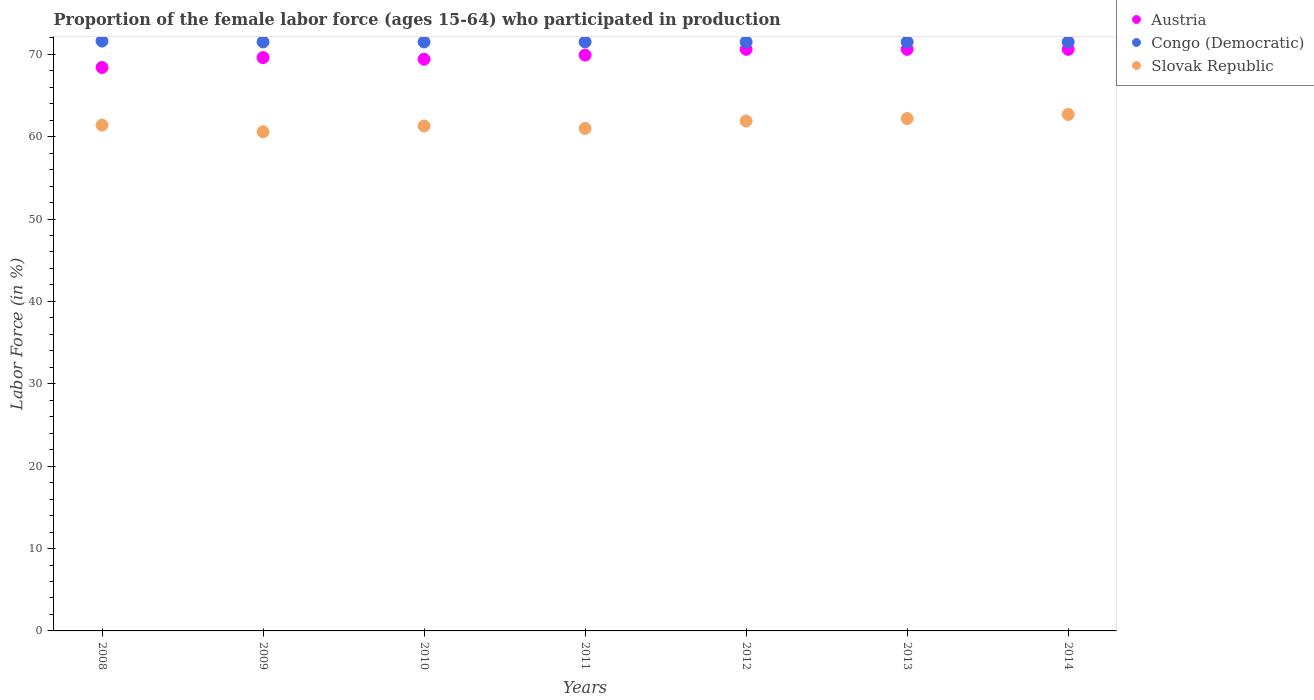How many different coloured dotlines are there?
Your answer should be compact. 3. Is the number of dotlines equal to the number of legend labels?
Ensure brevity in your answer.  Yes. What is the proportion of the female labor force who participated in production in Slovak Republic in 2012?
Keep it short and to the point. 61.9. Across all years, what is the maximum proportion of the female labor force who participated in production in Congo (Democratic)?
Offer a very short reply. 71.6. Across all years, what is the minimum proportion of the female labor force who participated in production in Austria?
Make the answer very short. 68.4. In which year was the proportion of the female labor force who participated in production in Congo (Democratic) minimum?
Offer a terse response. 2009. What is the total proportion of the female labor force who participated in production in Congo (Democratic) in the graph?
Your answer should be very brief. 500.6. What is the difference between the proportion of the female labor force who participated in production in Austria in 2011 and that in 2014?
Provide a succinct answer. -0.7. What is the difference between the proportion of the female labor force who participated in production in Congo (Democratic) in 2014 and the proportion of the female labor force who participated in production in Slovak Republic in 2012?
Make the answer very short. 9.6. What is the average proportion of the female labor force who participated in production in Austria per year?
Provide a short and direct response. 69.87. In the year 2014, what is the difference between the proportion of the female labor force who participated in production in Austria and proportion of the female labor force who participated in production in Congo (Democratic)?
Your answer should be very brief. -0.9. What is the ratio of the proportion of the female labor force who participated in production in Slovak Republic in 2008 to that in 2014?
Offer a very short reply. 0.98. Is the proportion of the female labor force who participated in production in Austria in 2008 less than that in 2014?
Offer a very short reply. Yes. Is the difference between the proportion of the female labor force who participated in production in Austria in 2008 and 2013 greater than the difference between the proportion of the female labor force who participated in production in Congo (Democratic) in 2008 and 2013?
Make the answer very short. No. What is the difference between the highest and the lowest proportion of the female labor force who participated in production in Austria?
Give a very brief answer. 2.2. Is the proportion of the female labor force who participated in production in Slovak Republic strictly less than the proportion of the female labor force who participated in production in Congo (Democratic) over the years?
Provide a succinct answer. Yes. How many years are there in the graph?
Offer a very short reply. 7. What is the difference between two consecutive major ticks on the Y-axis?
Offer a terse response. 10. Are the values on the major ticks of Y-axis written in scientific E-notation?
Your response must be concise. No. Does the graph contain grids?
Offer a terse response. No. Where does the legend appear in the graph?
Give a very brief answer. Top right. What is the title of the graph?
Give a very brief answer. Proportion of the female labor force (ages 15-64) who participated in production. What is the label or title of the X-axis?
Provide a succinct answer. Years. What is the label or title of the Y-axis?
Provide a short and direct response. Labor Force (in %). What is the Labor Force (in %) in Austria in 2008?
Your response must be concise. 68.4. What is the Labor Force (in %) in Congo (Democratic) in 2008?
Ensure brevity in your answer.  71.6. What is the Labor Force (in %) in Slovak Republic in 2008?
Provide a succinct answer. 61.4. What is the Labor Force (in %) in Austria in 2009?
Your answer should be compact. 69.6. What is the Labor Force (in %) of Congo (Democratic) in 2009?
Your answer should be compact. 71.5. What is the Labor Force (in %) of Slovak Republic in 2009?
Make the answer very short. 60.6. What is the Labor Force (in %) of Austria in 2010?
Your answer should be very brief. 69.4. What is the Labor Force (in %) in Congo (Democratic) in 2010?
Your response must be concise. 71.5. What is the Labor Force (in %) of Slovak Republic in 2010?
Your answer should be very brief. 61.3. What is the Labor Force (in %) of Austria in 2011?
Provide a succinct answer. 69.9. What is the Labor Force (in %) of Congo (Democratic) in 2011?
Provide a short and direct response. 71.5. What is the Labor Force (in %) of Slovak Republic in 2011?
Provide a succinct answer. 61. What is the Labor Force (in %) in Austria in 2012?
Ensure brevity in your answer.  70.6. What is the Labor Force (in %) of Congo (Democratic) in 2012?
Offer a terse response. 71.5. What is the Labor Force (in %) of Slovak Republic in 2012?
Your response must be concise. 61.9. What is the Labor Force (in %) in Austria in 2013?
Give a very brief answer. 70.6. What is the Labor Force (in %) in Congo (Democratic) in 2013?
Make the answer very short. 71.5. What is the Labor Force (in %) in Slovak Republic in 2013?
Keep it short and to the point. 62.2. What is the Labor Force (in %) of Austria in 2014?
Provide a succinct answer. 70.6. What is the Labor Force (in %) of Congo (Democratic) in 2014?
Keep it short and to the point. 71.5. What is the Labor Force (in %) of Slovak Republic in 2014?
Your answer should be very brief. 62.7. Across all years, what is the maximum Labor Force (in %) of Austria?
Provide a short and direct response. 70.6. Across all years, what is the maximum Labor Force (in %) of Congo (Democratic)?
Give a very brief answer. 71.6. Across all years, what is the maximum Labor Force (in %) of Slovak Republic?
Offer a very short reply. 62.7. Across all years, what is the minimum Labor Force (in %) in Austria?
Offer a terse response. 68.4. Across all years, what is the minimum Labor Force (in %) in Congo (Democratic)?
Provide a succinct answer. 71.5. Across all years, what is the minimum Labor Force (in %) in Slovak Republic?
Your response must be concise. 60.6. What is the total Labor Force (in %) in Austria in the graph?
Make the answer very short. 489.1. What is the total Labor Force (in %) in Congo (Democratic) in the graph?
Offer a very short reply. 500.6. What is the total Labor Force (in %) of Slovak Republic in the graph?
Provide a short and direct response. 431.1. What is the difference between the Labor Force (in %) of Congo (Democratic) in 2008 and that in 2009?
Make the answer very short. 0.1. What is the difference between the Labor Force (in %) of Slovak Republic in 2008 and that in 2009?
Provide a short and direct response. 0.8. What is the difference between the Labor Force (in %) in Slovak Republic in 2008 and that in 2010?
Provide a short and direct response. 0.1. What is the difference between the Labor Force (in %) of Congo (Democratic) in 2008 and that in 2011?
Keep it short and to the point. 0.1. What is the difference between the Labor Force (in %) of Slovak Republic in 2008 and that in 2011?
Keep it short and to the point. 0.4. What is the difference between the Labor Force (in %) in Slovak Republic in 2008 and that in 2012?
Offer a very short reply. -0.5. What is the difference between the Labor Force (in %) in Slovak Republic in 2008 and that in 2014?
Ensure brevity in your answer.  -1.3. What is the difference between the Labor Force (in %) of Austria in 2009 and that in 2010?
Ensure brevity in your answer.  0.2. What is the difference between the Labor Force (in %) in Slovak Republic in 2009 and that in 2010?
Your response must be concise. -0.7. What is the difference between the Labor Force (in %) in Austria in 2009 and that in 2011?
Give a very brief answer. -0.3. What is the difference between the Labor Force (in %) of Congo (Democratic) in 2009 and that in 2011?
Give a very brief answer. 0. What is the difference between the Labor Force (in %) in Austria in 2009 and that in 2012?
Your answer should be compact. -1. What is the difference between the Labor Force (in %) of Slovak Republic in 2009 and that in 2012?
Provide a succinct answer. -1.3. What is the difference between the Labor Force (in %) in Austria in 2009 and that in 2013?
Offer a very short reply. -1. What is the difference between the Labor Force (in %) in Congo (Democratic) in 2009 and that in 2013?
Provide a short and direct response. 0. What is the difference between the Labor Force (in %) of Slovak Republic in 2009 and that in 2013?
Offer a terse response. -1.6. What is the difference between the Labor Force (in %) of Congo (Democratic) in 2009 and that in 2014?
Give a very brief answer. 0. What is the difference between the Labor Force (in %) of Slovak Republic in 2009 and that in 2014?
Your response must be concise. -2.1. What is the difference between the Labor Force (in %) in Austria in 2010 and that in 2011?
Your answer should be compact. -0.5. What is the difference between the Labor Force (in %) in Congo (Democratic) in 2010 and that in 2011?
Provide a succinct answer. 0. What is the difference between the Labor Force (in %) in Slovak Republic in 2010 and that in 2011?
Give a very brief answer. 0.3. What is the difference between the Labor Force (in %) in Austria in 2010 and that in 2012?
Provide a succinct answer. -1.2. What is the difference between the Labor Force (in %) of Congo (Democratic) in 2010 and that in 2012?
Give a very brief answer. 0. What is the difference between the Labor Force (in %) of Congo (Democratic) in 2010 and that in 2014?
Your answer should be compact. 0. What is the difference between the Labor Force (in %) in Congo (Democratic) in 2011 and that in 2012?
Your answer should be very brief. 0. What is the difference between the Labor Force (in %) in Slovak Republic in 2011 and that in 2012?
Give a very brief answer. -0.9. What is the difference between the Labor Force (in %) of Congo (Democratic) in 2011 and that in 2013?
Keep it short and to the point. 0. What is the difference between the Labor Force (in %) in Slovak Republic in 2011 and that in 2013?
Give a very brief answer. -1.2. What is the difference between the Labor Force (in %) in Slovak Republic in 2012 and that in 2013?
Your response must be concise. -0.3. What is the difference between the Labor Force (in %) in Congo (Democratic) in 2012 and that in 2014?
Offer a terse response. 0. What is the difference between the Labor Force (in %) of Austria in 2008 and the Labor Force (in %) of Congo (Democratic) in 2009?
Give a very brief answer. -3.1. What is the difference between the Labor Force (in %) in Congo (Democratic) in 2008 and the Labor Force (in %) in Slovak Republic in 2009?
Your answer should be compact. 11. What is the difference between the Labor Force (in %) in Austria in 2008 and the Labor Force (in %) in Congo (Democratic) in 2010?
Your answer should be very brief. -3.1. What is the difference between the Labor Force (in %) of Austria in 2008 and the Labor Force (in %) of Slovak Republic in 2010?
Offer a terse response. 7.1. What is the difference between the Labor Force (in %) in Congo (Democratic) in 2008 and the Labor Force (in %) in Slovak Republic in 2010?
Your answer should be very brief. 10.3. What is the difference between the Labor Force (in %) of Austria in 2008 and the Labor Force (in %) of Congo (Democratic) in 2011?
Your response must be concise. -3.1. What is the difference between the Labor Force (in %) of Austria in 2008 and the Labor Force (in %) of Slovak Republic in 2011?
Offer a very short reply. 7.4. What is the difference between the Labor Force (in %) of Austria in 2008 and the Labor Force (in %) of Congo (Democratic) in 2012?
Offer a terse response. -3.1. What is the difference between the Labor Force (in %) in Austria in 2008 and the Labor Force (in %) in Slovak Republic in 2012?
Provide a succinct answer. 6.5. What is the difference between the Labor Force (in %) in Austria in 2008 and the Labor Force (in %) in Congo (Democratic) in 2013?
Keep it short and to the point. -3.1. What is the difference between the Labor Force (in %) of Congo (Democratic) in 2008 and the Labor Force (in %) of Slovak Republic in 2013?
Give a very brief answer. 9.4. What is the difference between the Labor Force (in %) in Congo (Democratic) in 2008 and the Labor Force (in %) in Slovak Republic in 2014?
Offer a very short reply. 8.9. What is the difference between the Labor Force (in %) of Congo (Democratic) in 2009 and the Labor Force (in %) of Slovak Republic in 2010?
Keep it short and to the point. 10.2. What is the difference between the Labor Force (in %) of Austria in 2009 and the Labor Force (in %) of Congo (Democratic) in 2011?
Provide a short and direct response. -1.9. What is the difference between the Labor Force (in %) in Austria in 2009 and the Labor Force (in %) in Slovak Republic in 2011?
Ensure brevity in your answer.  8.6. What is the difference between the Labor Force (in %) in Austria in 2009 and the Labor Force (in %) in Congo (Democratic) in 2012?
Offer a terse response. -1.9. What is the difference between the Labor Force (in %) of Austria in 2009 and the Labor Force (in %) of Slovak Republic in 2012?
Offer a very short reply. 7.7. What is the difference between the Labor Force (in %) of Congo (Democratic) in 2009 and the Labor Force (in %) of Slovak Republic in 2012?
Your answer should be very brief. 9.6. What is the difference between the Labor Force (in %) of Austria in 2009 and the Labor Force (in %) of Congo (Democratic) in 2013?
Keep it short and to the point. -1.9. What is the difference between the Labor Force (in %) in Austria in 2009 and the Labor Force (in %) in Congo (Democratic) in 2014?
Offer a terse response. -1.9. What is the difference between the Labor Force (in %) of Congo (Democratic) in 2009 and the Labor Force (in %) of Slovak Republic in 2014?
Provide a short and direct response. 8.8. What is the difference between the Labor Force (in %) in Congo (Democratic) in 2010 and the Labor Force (in %) in Slovak Republic in 2011?
Provide a succinct answer. 10.5. What is the difference between the Labor Force (in %) of Austria in 2010 and the Labor Force (in %) of Slovak Republic in 2012?
Make the answer very short. 7.5. What is the difference between the Labor Force (in %) in Austria in 2010 and the Labor Force (in %) in Slovak Republic in 2013?
Offer a terse response. 7.2. What is the difference between the Labor Force (in %) of Congo (Democratic) in 2010 and the Labor Force (in %) of Slovak Republic in 2013?
Ensure brevity in your answer.  9.3. What is the difference between the Labor Force (in %) in Austria in 2010 and the Labor Force (in %) in Slovak Republic in 2014?
Offer a terse response. 6.7. What is the difference between the Labor Force (in %) in Congo (Democratic) in 2010 and the Labor Force (in %) in Slovak Republic in 2014?
Your response must be concise. 8.8. What is the difference between the Labor Force (in %) of Austria in 2011 and the Labor Force (in %) of Congo (Democratic) in 2012?
Your response must be concise. -1.6. What is the difference between the Labor Force (in %) in Congo (Democratic) in 2011 and the Labor Force (in %) in Slovak Republic in 2013?
Give a very brief answer. 9.3. What is the difference between the Labor Force (in %) in Austria in 2011 and the Labor Force (in %) in Slovak Republic in 2014?
Offer a terse response. 7.2. What is the difference between the Labor Force (in %) of Austria in 2012 and the Labor Force (in %) of Congo (Democratic) in 2013?
Offer a terse response. -0.9. What is the difference between the Labor Force (in %) of Austria in 2012 and the Labor Force (in %) of Congo (Democratic) in 2014?
Your answer should be very brief. -0.9. What is the difference between the Labor Force (in %) in Austria in 2012 and the Labor Force (in %) in Slovak Republic in 2014?
Provide a short and direct response. 7.9. What is the difference between the Labor Force (in %) in Congo (Democratic) in 2012 and the Labor Force (in %) in Slovak Republic in 2014?
Ensure brevity in your answer.  8.8. What is the difference between the Labor Force (in %) of Congo (Democratic) in 2013 and the Labor Force (in %) of Slovak Republic in 2014?
Your response must be concise. 8.8. What is the average Labor Force (in %) of Austria per year?
Ensure brevity in your answer.  69.87. What is the average Labor Force (in %) in Congo (Democratic) per year?
Your answer should be very brief. 71.51. What is the average Labor Force (in %) in Slovak Republic per year?
Give a very brief answer. 61.59. In the year 2008, what is the difference between the Labor Force (in %) in Austria and Labor Force (in %) in Congo (Democratic)?
Your answer should be compact. -3.2. In the year 2009, what is the difference between the Labor Force (in %) of Austria and Labor Force (in %) of Congo (Democratic)?
Provide a succinct answer. -1.9. In the year 2009, what is the difference between the Labor Force (in %) of Congo (Democratic) and Labor Force (in %) of Slovak Republic?
Offer a very short reply. 10.9. In the year 2010, what is the difference between the Labor Force (in %) in Austria and Labor Force (in %) in Congo (Democratic)?
Offer a very short reply. -2.1. In the year 2010, what is the difference between the Labor Force (in %) in Congo (Democratic) and Labor Force (in %) in Slovak Republic?
Your answer should be very brief. 10.2. In the year 2011, what is the difference between the Labor Force (in %) in Austria and Labor Force (in %) in Congo (Democratic)?
Provide a short and direct response. -1.6. In the year 2011, what is the difference between the Labor Force (in %) of Congo (Democratic) and Labor Force (in %) of Slovak Republic?
Make the answer very short. 10.5. In the year 2013, what is the difference between the Labor Force (in %) of Austria and Labor Force (in %) of Congo (Democratic)?
Your answer should be very brief. -0.9. In the year 2013, what is the difference between the Labor Force (in %) of Austria and Labor Force (in %) of Slovak Republic?
Offer a very short reply. 8.4. In the year 2013, what is the difference between the Labor Force (in %) in Congo (Democratic) and Labor Force (in %) in Slovak Republic?
Make the answer very short. 9.3. In the year 2014, what is the difference between the Labor Force (in %) in Congo (Democratic) and Labor Force (in %) in Slovak Republic?
Offer a terse response. 8.8. What is the ratio of the Labor Force (in %) in Austria in 2008 to that in 2009?
Offer a terse response. 0.98. What is the ratio of the Labor Force (in %) of Congo (Democratic) in 2008 to that in 2009?
Ensure brevity in your answer.  1. What is the ratio of the Labor Force (in %) in Slovak Republic in 2008 to that in 2009?
Provide a short and direct response. 1.01. What is the ratio of the Labor Force (in %) of Austria in 2008 to that in 2010?
Provide a succinct answer. 0.99. What is the ratio of the Labor Force (in %) in Congo (Democratic) in 2008 to that in 2010?
Provide a short and direct response. 1. What is the ratio of the Labor Force (in %) of Austria in 2008 to that in 2011?
Provide a succinct answer. 0.98. What is the ratio of the Labor Force (in %) of Slovak Republic in 2008 to that in 2011?
Offer a terse response. 1.01. What is the ratio of the Labor Force (in %) in Austria in 2008 to that in 2012?
Offer a terse response. 0.97. What is the ratio of the Labor Force (in %) of Congo (Democratic) in 2008 to that in 2012?
Ensure brevity in your answer.  1. What is the ratio of the Labor Force (in %) in Slovak Republic in 2008 to that in 2012?
Provide a succinct answer. 0.99. What is the ratio of the Labor Force (in %) in Austria in 2008 to that in 2013?
Give a very brief answer. 0.97. What is the ratio of the Labor Force (in %) in Slovak Republic in 2008 to that in 2013?
Provide a short and direct response. 0.99. What is the ratio of the Labor Force (in %) of Austria in 2008 to that in 2014?
Give a very brief answer. 0.97. What is the ratio of the Labor Force (in %) of Congo (Democratic) in 2008 to that in 2014?
Your response must be concise. 1. What is the ratio of the Labor Force (in %) in Slovak Republic in 2008 to that in 2014?
Provide a short and direct response. 0.98. What is the ratio of the Labor Force (in %) of Slovak Republic in 2009 to that in 2010?
Provide a succinct answer. 0.99. What is the ratio of the Labor Force (in %) of Austria in 2009 to that in 2011?
Make the answer very short. 1. What is the ratio of the Labor Force (in %) in Congo (Democratic) in 2009 to that in 2011?
Your answer should be very brief. 1. What is the ratio of the Labor Force (in %) in Slovak Republic in 2009 to that in 2011?
Your response must be concise. 0.99. What is the ratio of the Labor Force (in %) in Austria in 2009 to that in 2012?
Provide a short and direct response. 0.99. What is the ratio of the Labor Force (in %) of Austria in 2009 to that in 2013?
Make the answer very short. 0.99. What is the ratio of the Labor Force (in %) of Slovak Republic in 2009 to that in 2013?
Offer a terse response. 0.97. What is the ratio of the Labor Force (in %) in Austria in 2009 to that in 2014?
Your answer should be compact. 0.99. What is the ratio of the Labor Force (in %) of Congo (Democratic) in 2009 to that in 2014?
Keep it short and to the point. 1. What is the ratio of the Labor Force (in %) of Slovak Republic in 2009 to that in 2014?
Provide a succinct answer. 0.97. What is the ratio of the Labor Force (in %) in Austria in 2010 to that in 2011?
Your response must be concise. 0.99. What is the ratio of the Labor Force (in %) in Austria in 2010 to that in 2012?
Keep it short and to the point. 0.98. What is the ratio of the Labor Force (in %) of Congo (Democratic) in 2010 to that in 2012?
Give a very brief answer. 1. What is the ratio of the Labor Force (in %) in Slovak Republic in 2010 to that in 2012?
Your response must be concise. 0.99. What is the ratio of the Labor Force (in %) in Austria in 2010 to that in 2013?
Offer a very short reply. 0.98. What is the ratio of the Labor Force (in %) of Congo (Democratic) in 2010 to that in 2013?
Your answer should be compact. 1. What is the ratio of the Labor Force (in %) in Slovak Republic in 2010 to that in 2013?
Make the answer very short. 0.99. What is the ratio of the Labor Force (in %) of Austria in 2010 to that in 2014?
Offer a very short reply. 0.98. What is the ratio of the Labor Force (in %) of Congo (Democratic) in 2010 to that in 2014?
Provide a short and direct response. 1. What is the ratio of the Labor Force (in %) of Slovak Republic in 2010 to that in 2014?
Give a very brief answer. 0.98. What is the ratio of the Labor Force (in %) in Slovak Republic in 2011 to that in 2012?
Your answer should be very brief. 0.99. What is the ratio of the Labor Force (in %) of Congo (Democratic) in 2011 to that in 2013?
Keep it short and to the point. 1. What is the ratio of the Labor Force (in %) in Slovak Republic in 2011 to that in 2013?
Your answer should be compact. 0.98. What is the ratio of the Labor Force (in %) of Slovak Republic in 2011 to that in 2014?
Ensure brevity in your answer.  0.97. What is the ratio of the Labor Force (in %) in Congo (Democratic) in 2012 to that in 2013?
Give a very brief answer. 1. What is the ratio of the Labor Force (in %) of Austria in 2012 to that in 2014?
Give a very brief answer. 1. What is the ratio of the Labor Force (in %) of Slovak Republic in 2012 to that in 2014?
Offer a very short reply. 0.99. What is the ratio of the Labor Force (in %) in Austria in 2013 to that in 2014?
Your answer should be very brief. 1. What is the ratio of the Labor Force (in %) in Congo (Democratic) in 2013 to that in 2014?
Provide a succinct answer. 1. What is the ratio of the Labor Force (in %) in Slovak Republic in 2013 to that in 2014?
Your answer should be compact. 0.99. What is the difference between the highest and the second highest Labor Force (in %) of Congo (Democratic)?
Offer a very short reply. 0.1. What is the difference between the highest and the lowest Labor Force (in %) in Congo (Democratic)?
Provide a succinct answer. 0.1. What is the difference between the highest and the lowest Labor Force (in %) in Slovak Republic?
Provide a succinct answer. 2.1. 